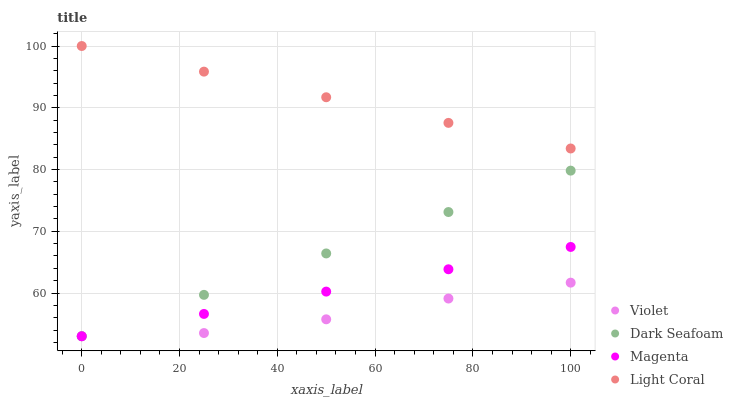Does Violet have the minimum area under the curve?
Answer yes or no. Yes. Does Light Coral have the maximum area under the curve?
Answer yes or no. Yes. Does Dark Seafoam have the minimum area under the curve?
Answer yes or no. No. Does Dark Seafoam have the maximum area under the curve?
Answer yes or no. No. Is Magenta the smoothest?
Answer yes or no. Yes. Is Violet the roughest?
Answer yes or no. Yes. Is Dark Seafoam the smoothest?
Answer yes or no. No. Is Dark Seafoam the roughest?
Answer yes or no. No. Does Dark Seafoam have the lowest value?
Answer yes or no. Yes. Does Light Coral have the highest value?
Answer yes or no. Yes. Does Dark Seafoam have the highest value?
Answer yes or no. No. Is Magenta less than Light Coral?
Answer yes or no. Yes. Is Light Coral greater than Dark Seafoam?
Answer yes or no. Yes. Does Violet intersect Magenta?
Answer yes or no. Yes. Is Violet less than Magenta?
Answer yes or no. No. Is Violet greater than Magenta?
Answer yes or no. No. Does Magenta intersect Light Coral?
Answer yes or no. No. 